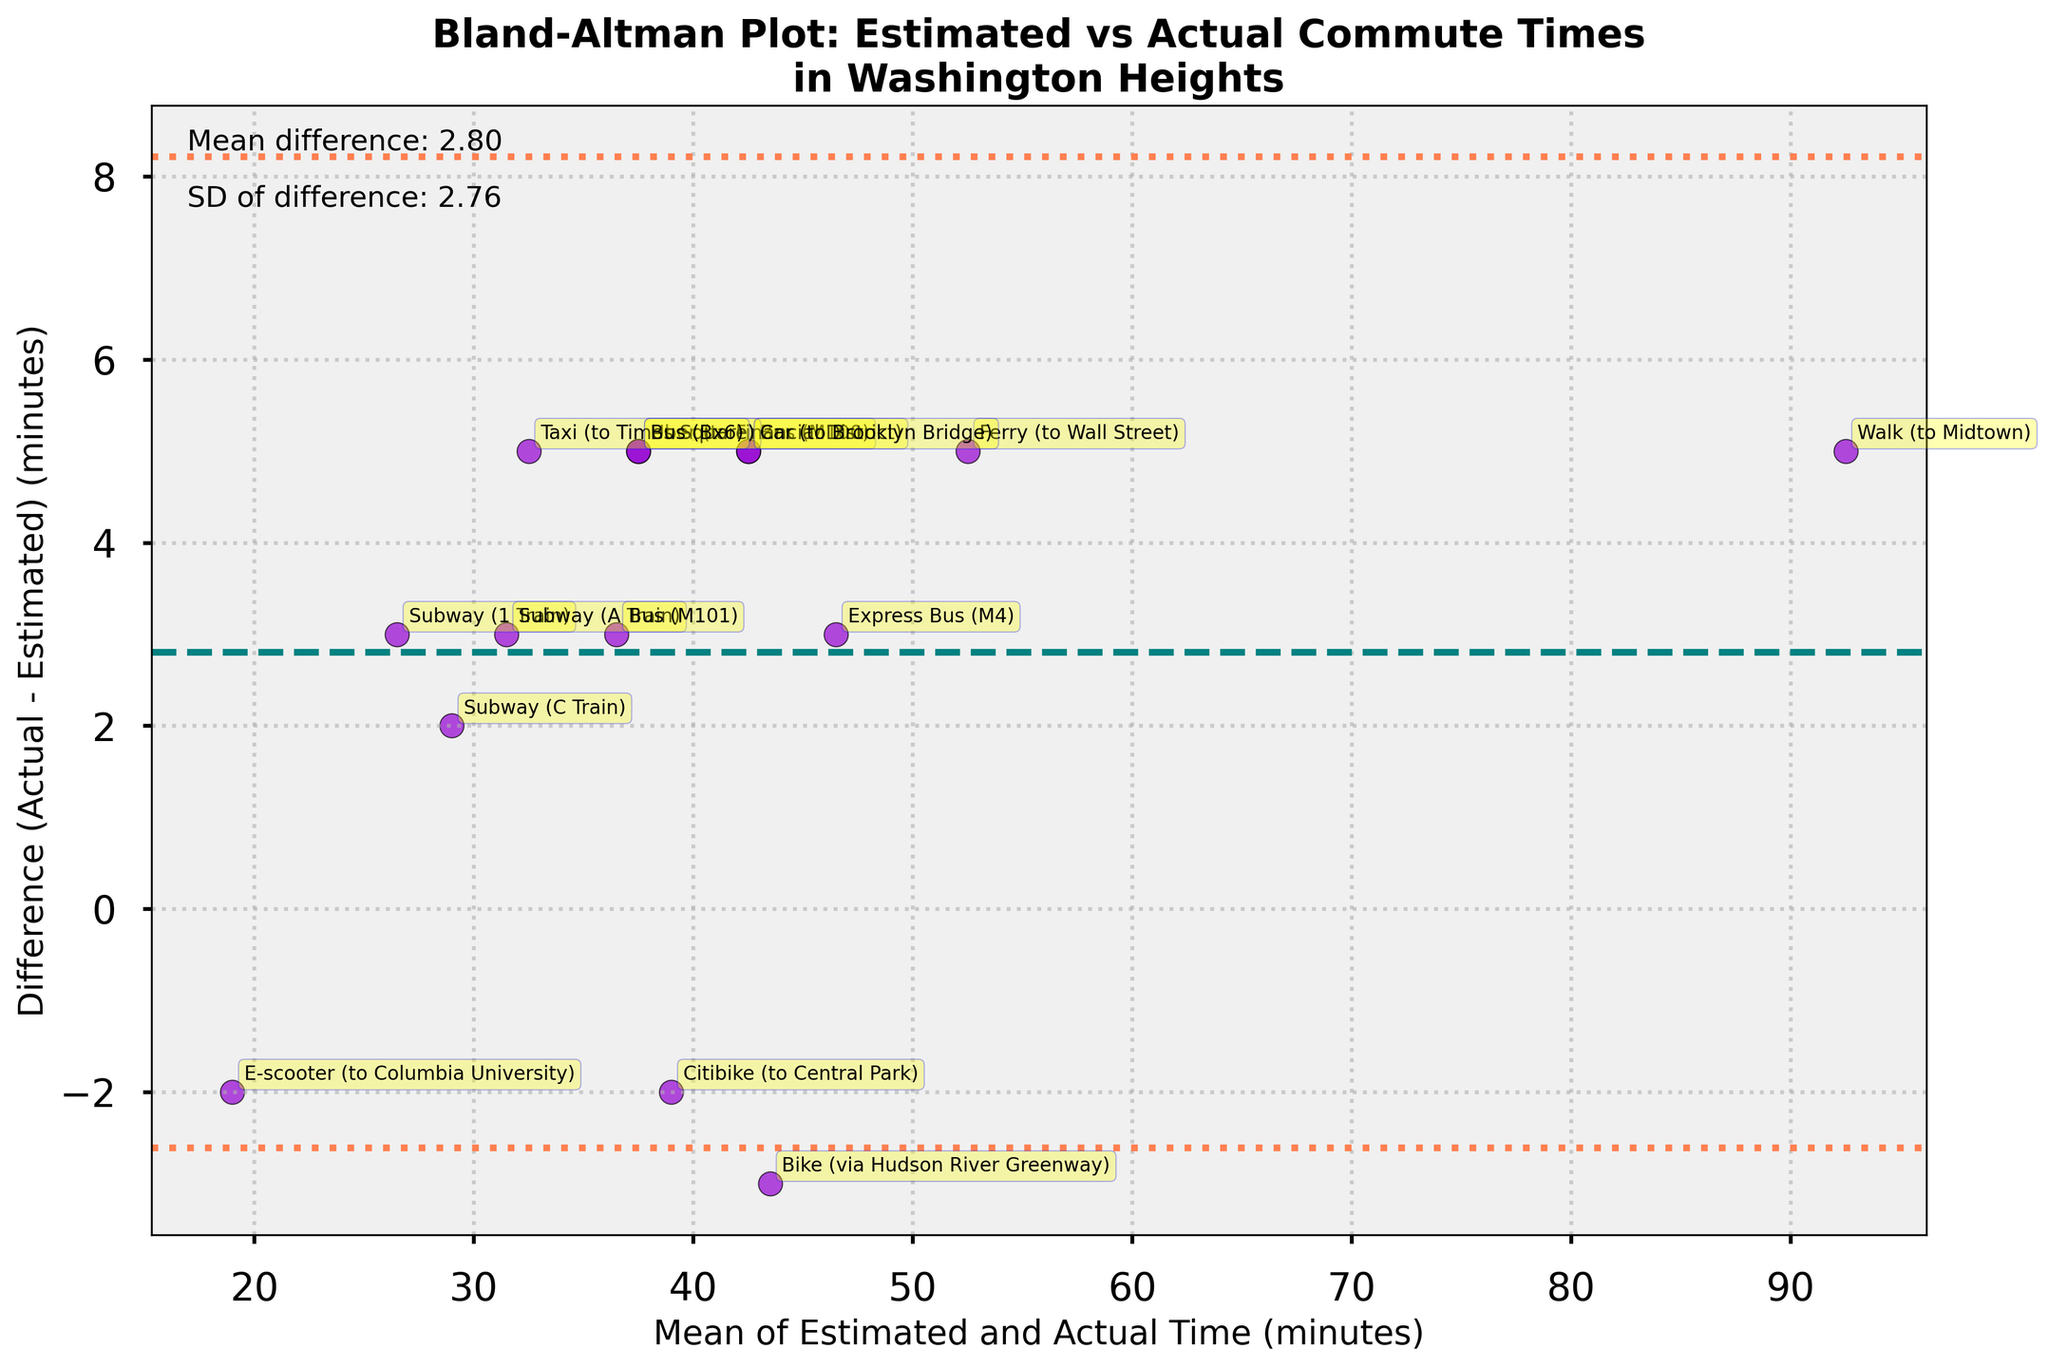How many data points are represented in the plot? By counting the number of distinct annotations or scatter points on the plot
Answer: 15 What is the title of the plot? The title is located at the top of the plot and often represented in bold text
Answer: Bland-Altman Plot: Estimated vs Actual Commute Times in Washington Heights What does the darkviolet scatter point with the smallest mean difference represent? The scatter point is annotated with the commuter type, and the smallest mean difference is closest to the x-axis
Answer: E-scooter (to Columbia University) What is the mean difference between actual and estimated commute times shown by the dashed line? The mean difference is indicated by the horizontal dashed line and a text annotation on the plot
Answer: Approximately 2.47 minutes Which method has the largest positive difference between actual and estimated commute times? Identify the scatter point farthest above the x-axis and refer to its label
Answer: Ferry (to Wall Street) Which commuter method falls below the mean difference by the greatest amount? Find the lowest point below the mean difference (dashed line) and identify the corresponding annotation
Answer: E-scooter (to Columbia University) What are the values of the upper and lower limits of agreement? These are represented by the horizontal dotted lines, calculated as mean difference ± 1.96 times the standard deviation
Answer: Upper limit: ~10.79, Lower limit: ~-5.85 How is the standard deviation of the differences represented in the plot? Look for the annotation indicating standard deviation, and refer to its value
Answer: Standard deviation is ~4.25 If we consider the difference of 'Bike (via Hudson River Greenway)', what is its approximate value? Find the annotated point for 'Bike (via Hudson River Greenway)' on the plot and note its y-coordinate (difference)
Answer: Approximately -3 Are there any commuter methods with a perfect match between estimated and actual commute times? Check for any scatter points exactly on the line y=0 (no difference)
Answer: No 